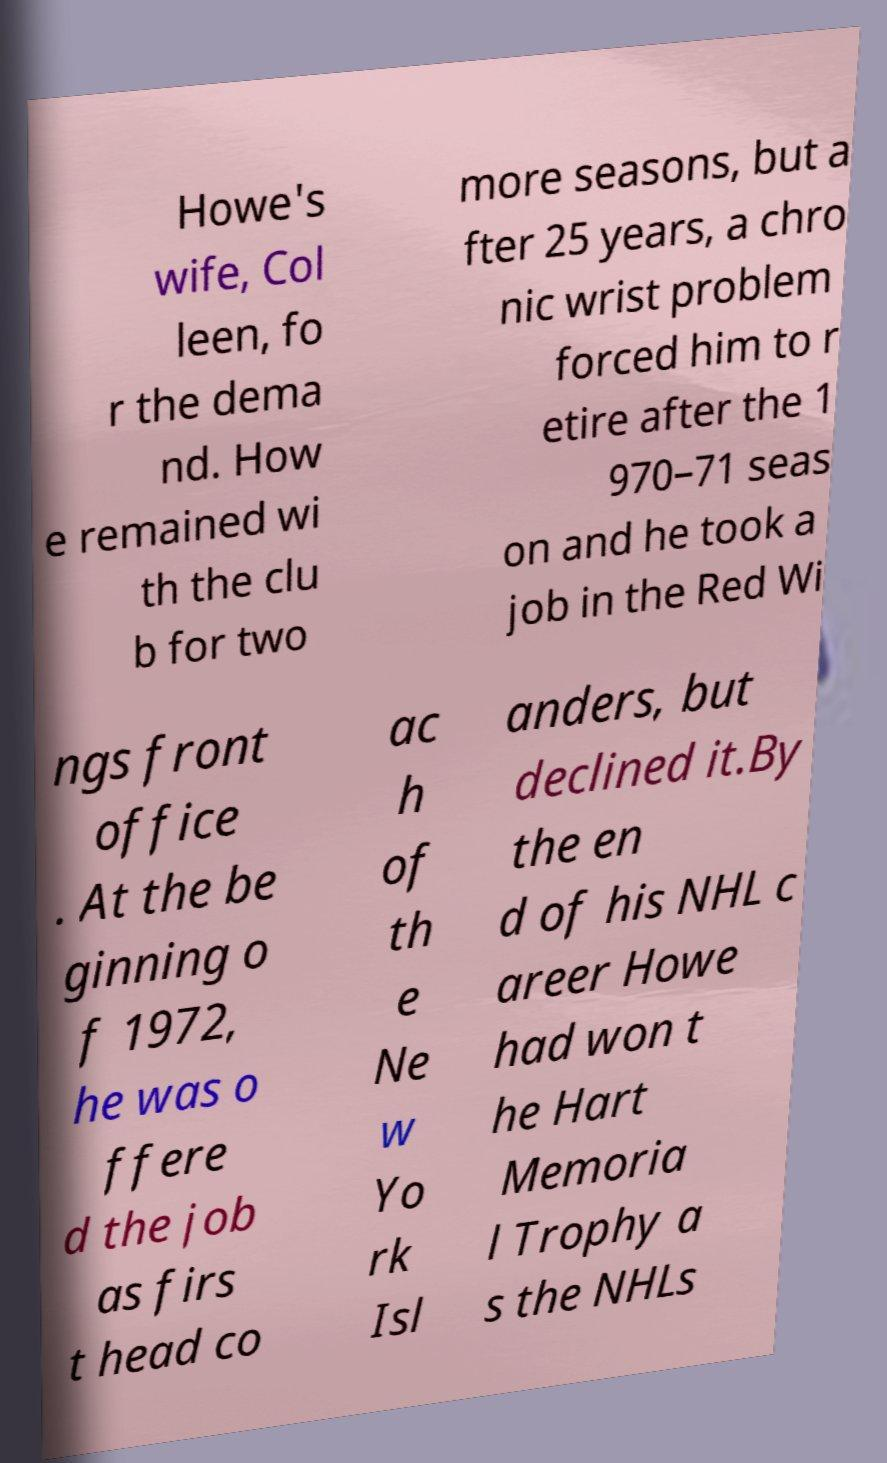Can you accurately transcribe the text from the provided image for me? Howe's wife, Col leen, fo r the dema nd. How e remained wi th the clu b for two more seasons, but a fter 25 years, a chro nic wrist problem forced him to r etire after the 1 970–71 seas on and he took a job in the Red Wi ngs front office . At the be ginning o f 1972, he was o ffere d the job as firs t head co ac h of th e Ne w Yo rk Isl anders, but declined it.By the en d of his NHL c areer Howe had won t he Hart Memoria l Trophy a s the NHLs 